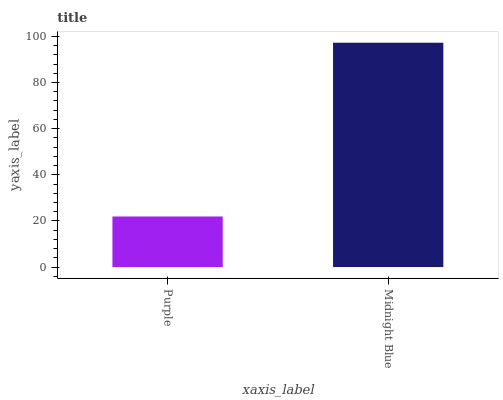Is Midnight Blue the minimum?
Answer yes or no. No. Is Midnight Blue greater than Purple?
Answer yes or no. Yes. Is Purple less than Midnight Blue?
Answer yes or no. Yes. Is Purple greater than Midnight Blue?
Answer yes or no. No. Is Midnight Blue less than Purple?
Answer yes or no. No. Is Midnight Blue the high median?
Answer yes or no. Yes. Is Purple the low median?
Answer yes or no. Yes. Is Purple the high median?
Answer yes or no. No. Is Midnight Blue the low median?
Answer yes or no. No. 